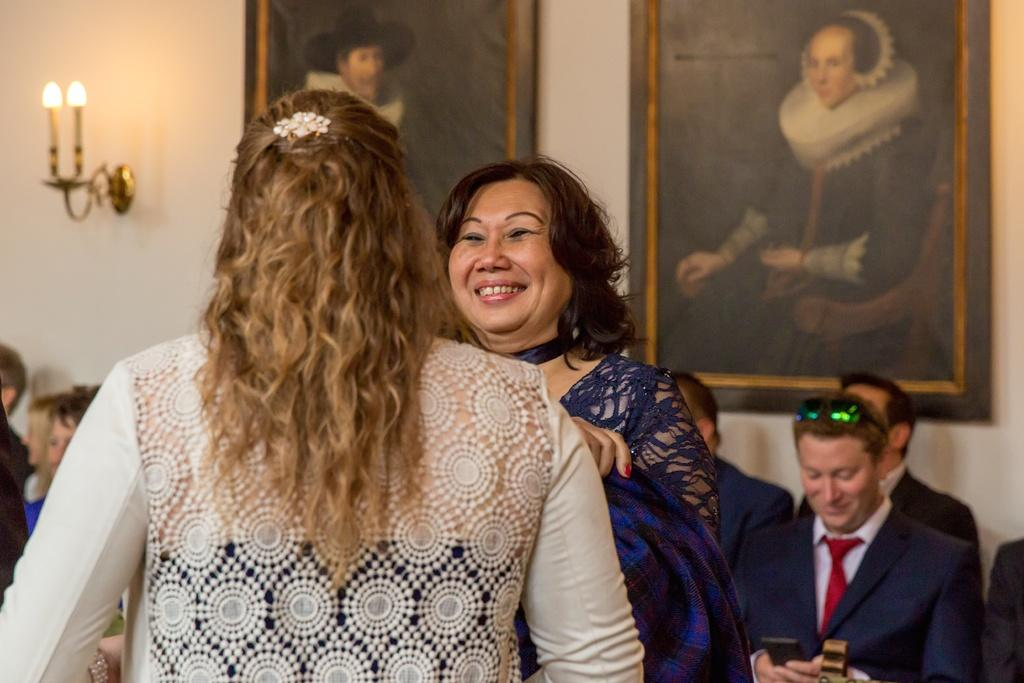How many people are in the image? There are people in the image, but the exact number is not specified. Can you describe the expressions of the people in the image? Some of the people are smiling in the image. What is visible in the background of the image? There is a wall in the background of the image. What is attached to the wall? There are lights on the wall and two photos attached to the wall. What type of curtain is hanging from the wall in the image? There is no curtain present in the image; only a wall with lights and photos is visible. Can you describe the locket that one of the people is wearing in the image? There is no mention of a locket or any jewelry in the image. What color is the vest that one of the people is wearing in the image? There is no mention of a vest or any clothing details in the image. 